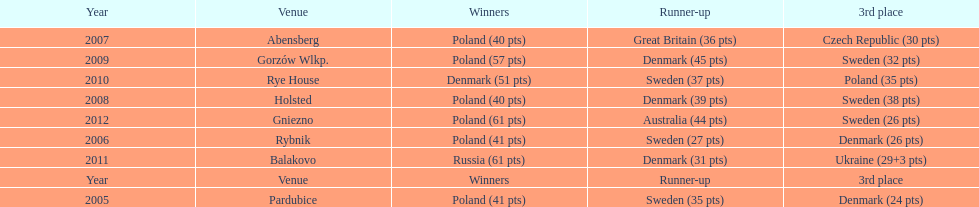After 2008 how many points total were scored by winners? 230. 